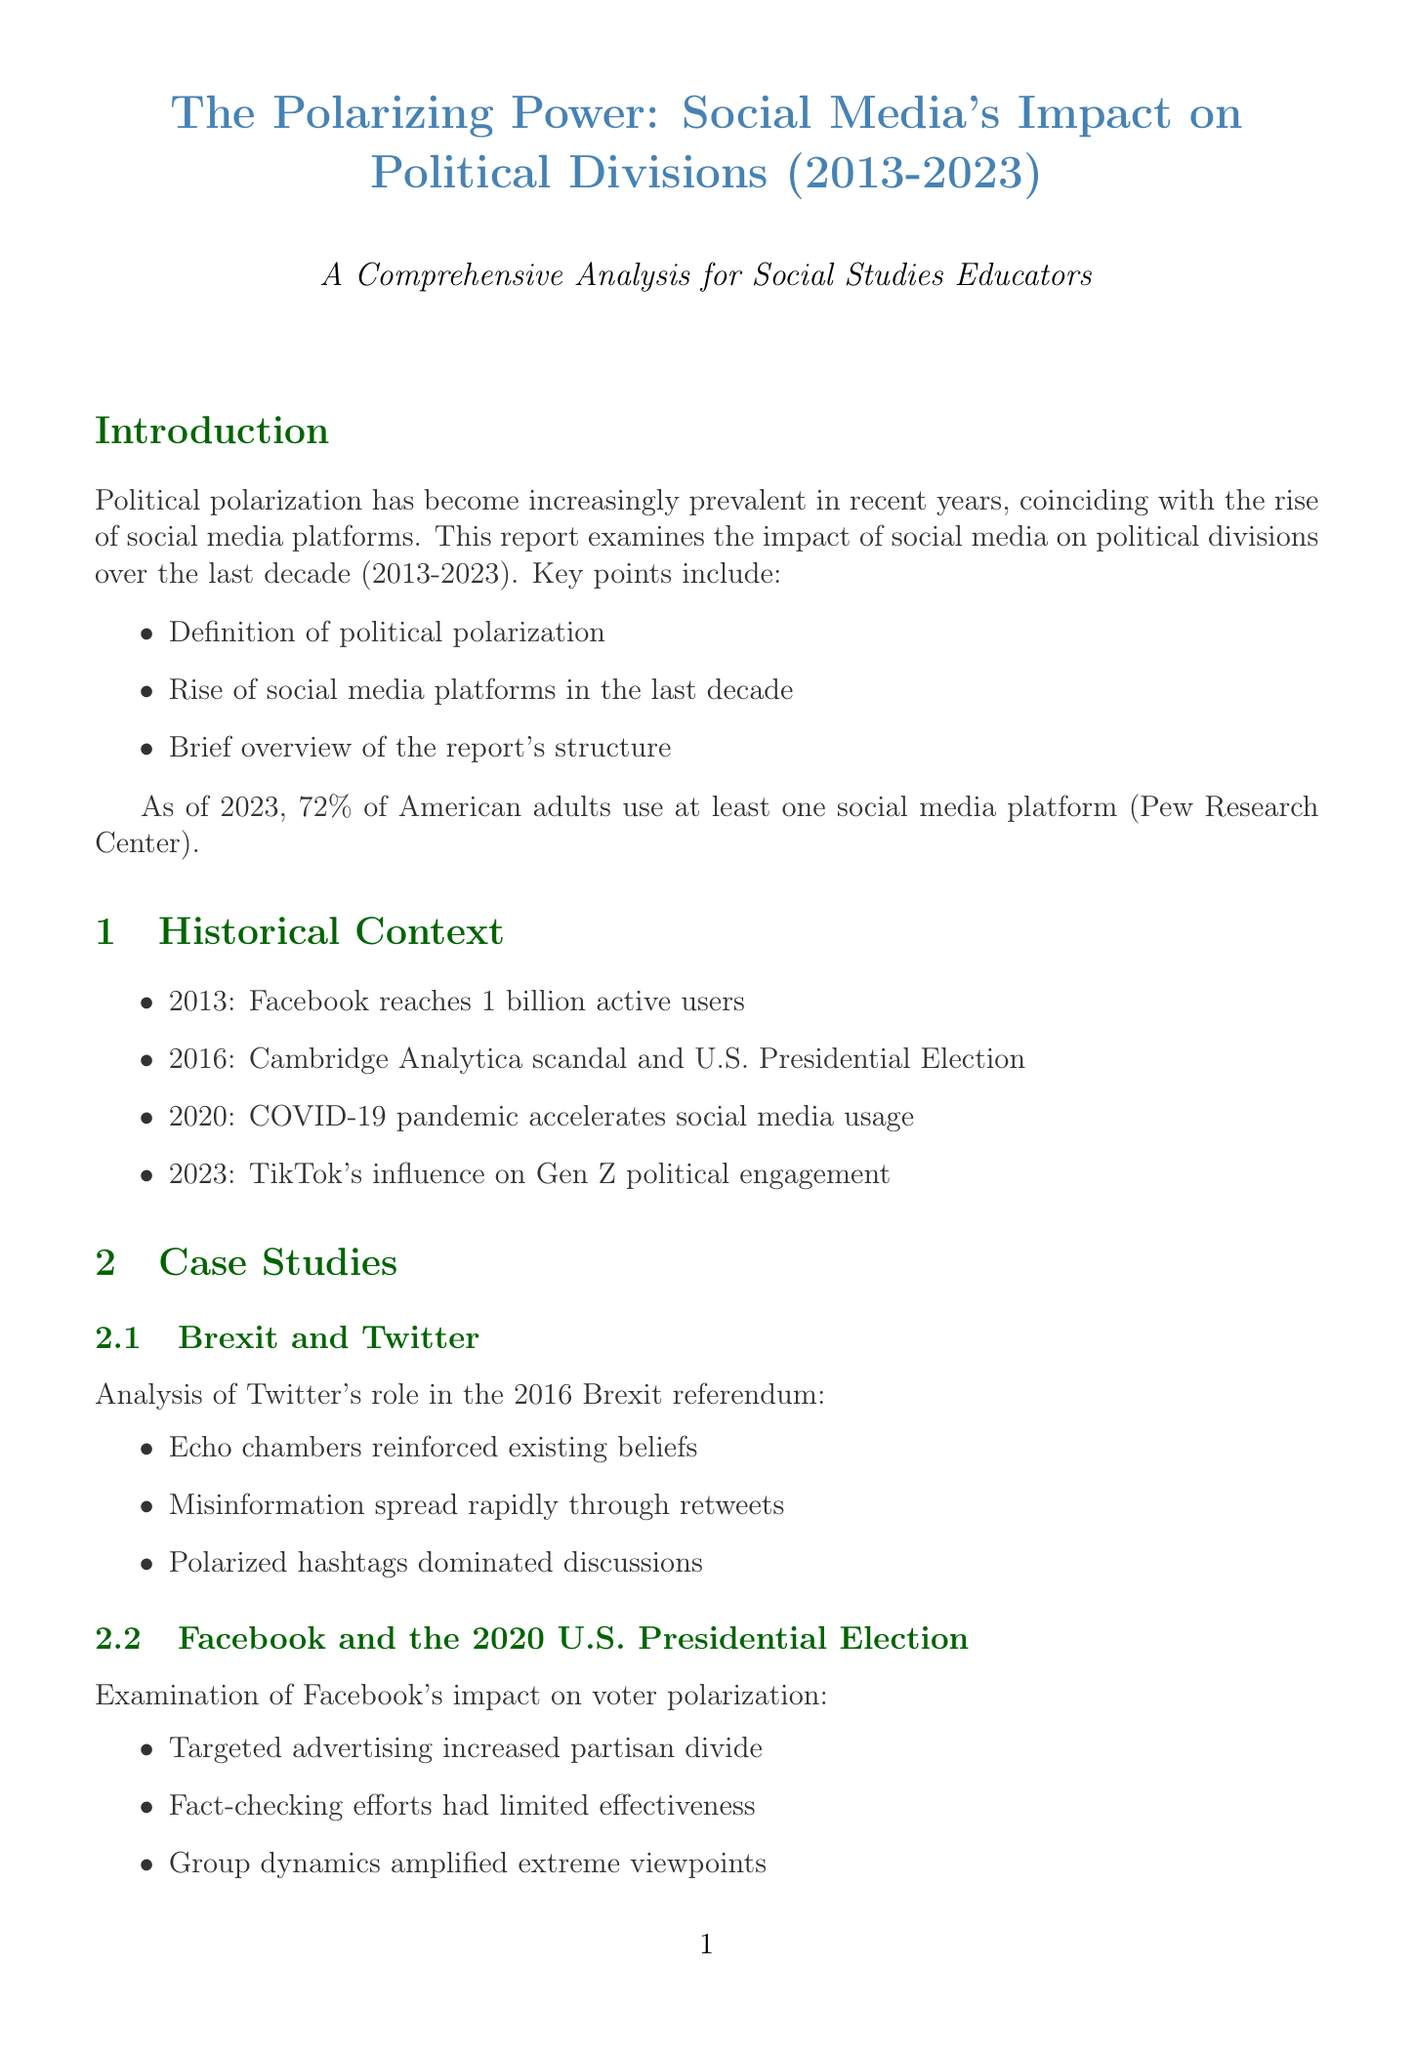What is the title of the report? The title provides a summary of the report's focus area, which revolves around social media's role in political division between 2013 and 2023.
Answer: The Polarizing Power: Social Media's Impact on Political Divisions (2013-2023) What percentage of American adults used social media as of 2023? The report references a statistic that highlights the extensive use of social media among American adults in 2023.
Answer: 72% What year did Facebook reach 1 billion active users? The timeline of events includes key milestones in social media history, with this being one significant landmark.
Answer: 2013 What was one key finding from the Brexit case study? The analysis of Twitter's role in the Brexit referendum outlines significant effects social media had on public opinion and discussion.
Answer: Echo chambers reinforced existing beliefs Which platform's targeted advertising increased the partisan divide during the 2020 U.S. Presidential Election? The report assesses how social media platforms influenced political activities, with specific focus on Facebook's impact.
Answer: Facebook Who is the author of the quote regarding social media algorithms prioritizing engagement? Expert opinions provide insights on the role of social media in political polarization, naming individuals who study this impact.
Answer: Dr. Safiya Noble What is one classroom strategy suggested in the report for addressing media literacy? The report outlines several strategies for educators to help students critically engage with media content.
Answer: Teaching critical media literacy What type of data visualization is the Political Polarization Index? The document categorizes various visual representations of data, highlighting the nature of political polarization trends over time.
Answer: Line graph 